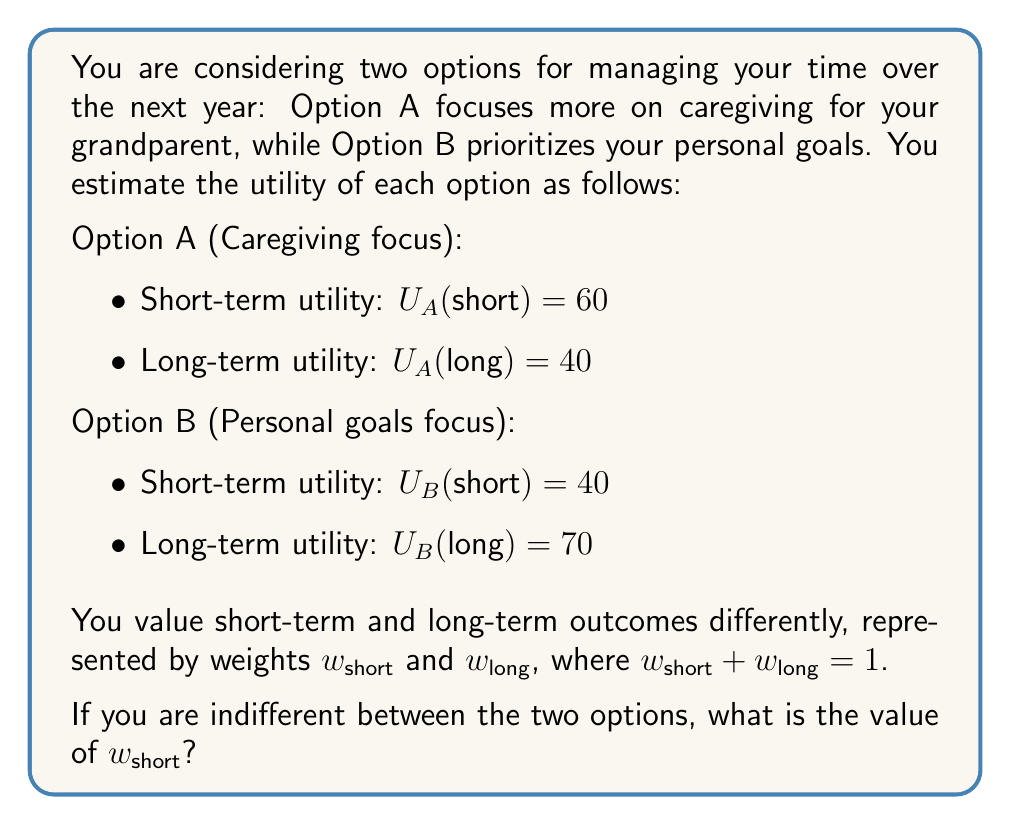Provide a solution to this math problem. To solve this problem, we need to use utility functions and the concept of indifference in decision theory. Let's approach this step-by-step:

1) First, let's define the total utility function for each option:

   $U_A = w_{short} \cdot U_A(short) + w_{long} \cdot U_A(long)$
   $U_B = w_{short} \cdot U_B(short) + w_{long} \cdot U_B(long)$

2) We're told that you're indifferent between the two options, which means their total utilities are equal:

   $U_A = U_B$

3) Let's substitute the given values:

   $w_{short} \cdot 60 + w_{long} \cdot 40 = w_{short} \cdot 40 + w_{long} \cdot 70$

4) We know that $w_{short} + w_{long} = 1$, so we can substitute $w_{long} = 1 - w_{short}$:

   $w_{short} \cdot 60 + (1 - w_{short}) \cdot 40 = w_{short} \cdot 40 + (1 - w_{short}) \cdot 70$

5) Let's expand this equation:

   $60w_{short} + 40 - 40w_{short} = 40w_{short} + 70 - 70w_{short}$

6) Simplify:

   $20w_{short} + 40 = -30w_{short} + 70$

7) Add $30w_{short}$ to both sides:

   $50w_{short} + 40 = 70$

8) Subtract 40 from both sides:

   $50w_{short} = 30$

9) Divide both sides by 50:

   $w_{short} = \frac{30}{50} = 0.6$

Therefore, the value of $w_{short}$ that makes you indifferent between the two options is 0.6.
Answer: $w_{short} = 0.6$ 